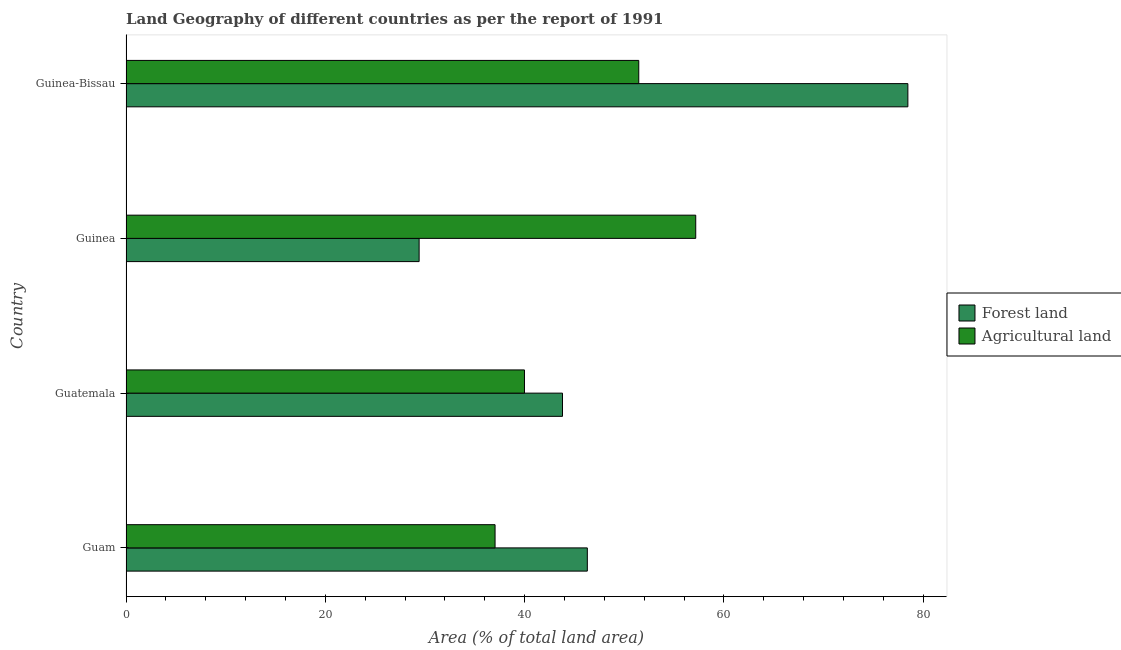How many groups of bars are there?
Your answer should be very brief. 4. Are the number of bars per tick equal to the number of legend labels?
Provide a short and direct response. Yes. Are the number of bars on each tick of the Y-axis equal?
Offer a terse response. Yes. How many bars are there on the 2nd tick from the top?
Your answer should be compact. 2. What is the label of the 3rd group of bars from the top?
Provide a short and direct response. Guatemala. In how many cases, is the number of bars for a given country not equal to the number of legend labels?
Ensure brevity in your answer.  0. What is the percentage of land area under agriculture in Guam?
Offer a very short reply. 37.04. Across all countries, what is the maximum percentage of land area under forests?
Give a very brief answer. 78.46. Across all countries, what is the minimum percentage of land area under forests?
Offer a very short reply. 29.42. In which country was the percentage of land area under forests maximum?
Provide a short and direct response. Guinea-Bissau. In which country was the percentage of land area under agriculture minimum?
Give a very brief answer. Guam. What is the total percentage of land area under agriculture in the graph?
Your answer should be very brief. 185.66. What is the difference between the percentage of land area under forests in Guatemala and that in Guinea-Bissau?
Your answer should be very brief. -34.66. What is the difference between the percentage of land area under forests in Guinea and the percentage of land area under agriculture in Guam?
Offer a very short reply. -7.62. What is the average percentage of land area under forests per country?
Offer a very short reply. 49.49. What is the difference between the percentage of land area under forests and percentage of land area under agriculture in Guatemala?
Make the answer very short. 3.82. What is the ratio of the percentage of land area under forests in Guinea to that in Guinea-Bissau?
Provide a succinct answer. 0.38. What is the difference between the highest and the second highest percentage of land area under forests?
Your answer should be compact. 32.17. What is the difference between the highest and the lowest percentage of land area under agriculture?
Offer a terse response. 20.14. In how many countries, is the percentage of land area under forests greater than the average percentage of land area under forests taken over all countries?
Your answer should be very brief. 1. What does the 1st bar from the top in Guinea-Bissau represents?
Your response must be concise. Agricultural land. What does the 1st bar from the bottom in Guinea-Bissau represents?
Offer a very short reply. Forest land. Are all the bars in the graph horizontal?
Your answer should be very brief. Yes. How many countries are there in the graph?
Make the answer very short. 4. Are the values on the major ticks of X-axis written in scientific E-notation?
Provide a short and direct response. No. Does the graph contain any zero values?
Provide a succinct answer. No. Does the graph contain grids?
Your answer should be very brief. No. How many legend labels are there?
Provide a succinct answer. 2. How are the legend labels stacked?
Give a very brief answer. Vertical. What is the title of the graph?
Offer a very short reply. Land Geography of different countries as per the report of 1991. What is the label or title of the X-axis?
Ensure brevity in your answer.  Area (% of total land area). What is the label or title of the Y-axis?
Your response must be concise. Country. What is the Area (% of total land area) of Forest land in Guam?
Give a very brief answer. 46.3. What is the Area (% of total land area) of Agricultural land in Guam?
Give a very brief answer. 37.04. What is the Area (% of total land area) of Forest land in Guatemala?
Provide a short and direct response. 43.8. What is the Area (% of total land area) in Agricultural land in Guatemala?
Give a very brief answer. 39.99. What is the Area (% of total land area) of Forest land in Guinea?
Your response must be concise. 29.42. What is the Area (% of total land area) in Agricultural land in Guinea?
Your response must be concise. 57.17. What is the Area (% of total land area) in Forest land in Guinea-Bissau?
Make the answer very short. 78.46. What is the Area (% of total land area) in Agricultural land in Guinea-Bissau?
Provide a succinct answer. 51.46. Across all countries, what is the maximum Area (% of total land area) in Forest land?
Your response must be concise. 78.46. Across all countries, what is the maximum Area (% of total land area) of Agricultural land?
Ensure brevity in your answer.  57.17. Across all countries, what is the minimum Area (% of total land area) of Forest land?
Give a very brief answer. 29.42. Across all countries, what is the minimum Area (% of total land area) in Agricultural land?
Offer a very short reply. 37.04. What is the total Area (% of total land area) of Forest land in the graph?
Your response must be concise. 197.98. What is the total Area (% of total land area) of Agricultural land in the graph?
Your response must be concise. 185.66. What is the difference between the Area (% of total land area) in Forest land in Guam and that in Guatemala?
Your answer should be compact. 2.49. What is the difference between the Area (% of total land area) in Agricultural land in Guam and that in Guatemala?
Ensure brevity in your answer.  -2.95. What is the difference between the Area (% of total land area) in Forest land in Guam and that in Guinea?
Make the answer very short. 16.88. What is the difference between the Area (% of total land area) in Agricultural land in Guam and that in Guinea?
Provide a succinct answer. -20.14. What is the difference between the Area (% of total land area) in Forest land in Guam and that in Guinea-Bissau?
Provide a succinct answer. -32.17. What is the difference between the Area (% of total land area) in Agricultural land in Guam and that in Guinea-Bissau?
Offer a terse response. -14.42. What is the difference between the Area (% of total land area) in Forest land in Guatemala and that in Guinea?
Make the answer very short. 14.39. What is the difference between the Area (% of total land area) of Agricultural land in Guatemala and that in Guinea?
Your answer should be compact. -17.19. What is the difference between the Area (% of total land area) of Forest land in Guatemala and that in Guinea-Bissau?
Your answer should be very brief. -34.66. What is the difference between the Area (% of total land area) of Agricultural land in Guatemala and that in Guinea-Bissau?
Keep it short and to the point. -11.47. What is the difference between the Area (% of total land area) of Forest land in Guinea and that in Guinea-Bissau?
Your response must be concise. -49.05. What is the difference between the Area (% of total land area) in Agricultural land in Guinea and that in Guinea-Bissau?
Your answer should be compact. 5.72. What is the difference between the Area (% of total land area) in Forest land in Guam and the Area (% of total land area) in Agricultural land in Guatemala?
Provide a succinct answer. 6.31. What is the difference between the Area (% of total land area) of Forest land in Guam and the Area (% of total land area) of Agricultural land in Guinea?
Provide a short and direct response. -10.88. What is the difference between the Area (% of total land area) in Forest land in Guam and the Area (% of total land area) in Agricultural land in Guinea-Bissau?
Provide a succinct answer. -5.16. What is the difference between the Area (% of total land area) in Forest land in Guatemala and the Area (% of total land area) in Agricultural land in Guinea?
Make the answer very short. -13.37. What is the difference between the Area (% of total land area) in Forest land in Guatemala and the Area (% of total land area) in Agricultural land in Guinea-Bissau?
Your response must be concise. -7.65. What is the difference between the Area (% of total land area) in Forest land in Guinea and the Area (% of total land area) in Agricultural land in Guinea-Bissau?
Your answer should be compact. -22.04. What is the average Area (% of total land area) of Forest land per country?
Your answer should be compact. 49.49. What is the average Area (% of total land area) of Agricultural land per country?
Your answer should be very brief. 46.41. What is the difference between the Area (% of total land area) of Forest land and Area (% of total land area) of Agricultural land in Guam?
Your answer should be very brief. 9.26. What is the difference between the Area (% of total land area) of Forest land and Area (% of total land area) of Agricultural land in Guatemala?
Offer a very short reply. 3.82. What is the difference between the Area (% of total land area) in Forest land and Area (% of total land area) in Agricultural land in Guinea?
Offer a terse response. -27.76. What is the difference between the Area (% of total land area) in Forest land and Area (% of total land area) in Agricultural land in Guinea-Bissau?
Your answer should be very brief. 27.01. What is the ratio of the Area (% of total land area) of Forest land in Guam to that in Guatemala?
Ensure brevity in your answer.  1.06. What is the ratio of the Area (% of total land area) in Agricultural land in Guam to that in Guatemala?
Your response must be concise. 0.93. What is the ratio of the Area (% of total land area) of Forest land in Guam to that in Guinea?
Ensure brevity in your answer.  1.57. What is the ratio of the Area (% of total land area) of Agricultural land in Guam to that in Guinea?
Offer a terse response. 0.65. What is the ratio of the Area (% of total land area) in Forest land in Guam to that in Guinea-Bissau?
Ensure brevity in your answer.  0.59. What is the ratio of the Area (% of total land area) of Agricultural land in Guam to that in Guinea-Bissau?
Provide a succinct answer. 0.72. What is the ratio of the Area (% of total land area) of Forest land in Guatemala to that in Guinea?
Your response must be concise. 1.49. What is the ratio of the Area (% of total land area) of Agricultural land in Guatemala to that in Guinea?
Provide a short and direct response. 0.7. What is the ratio of the Area (% of total land area) of Forest land in Guatemala to that in Guinea-Bissau?
Your answer should be very brief. 0.56. What is the ratio of the Area (% of total land area) of Agricultural land in Guatemala to that in Guinea-Bissau?
Keep it short and to the point. 0.78. What is the ratio of the Area (% of total land area) of Forest land in Guinea to that in Guinea-Bissau?
Offer a terse response. 0.37. What is the difference between the highest and the second highest Area (% of total land area) in Forest land?
Make the answer very short. 32.17. What is the difference between the highest and the second highest Area (% of total land area) in Agricultural land?
Offer a very short reply. 5.72. What is the difference between the highest and the lowest Area (% of total land area) of Forest land?
Offer a terse response. 49.05. What is the difference between the highest and the lowest Area (% of total land area) in Agricultural land?
Keep it short and to the point. 20.14. 